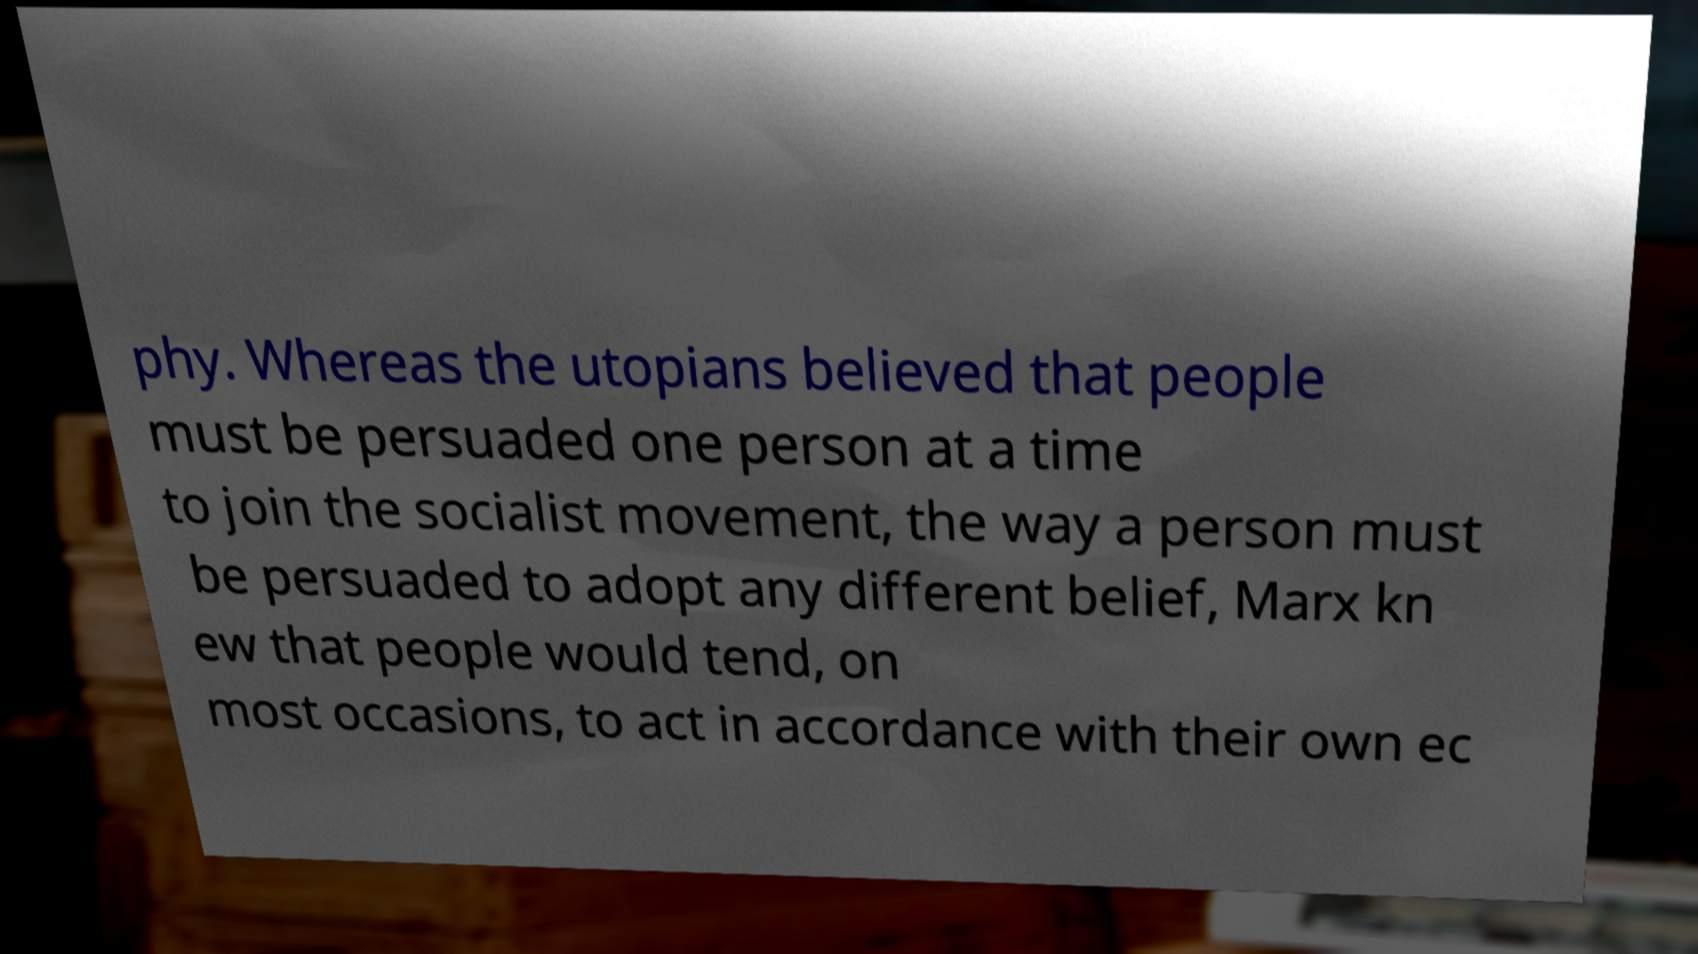Can you accurately transcribe the text from the provided image for me? phy. Whereas the utopians believed that people must be persuaded one person at a time to join the socialist movement, the way a person must be persuaded to adopt any different belief, Marx kn ew that people would tend, on most occasions, to act in accordance with their own ec 